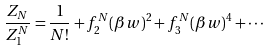Convert formula to latex. <formula><loc_0><loc_0><loc_500><loc_500>\frac { Z _ { N } } { Z ^ { N } _ { 1 } } = \frac { 1 } { N ! } + f ^ { N } _ { 2 } ( \beta w ) ^ { 2 } + f ^ { N } _ { 3 } ( \beta w ) ^ { 4 } + \cdots</formula> 